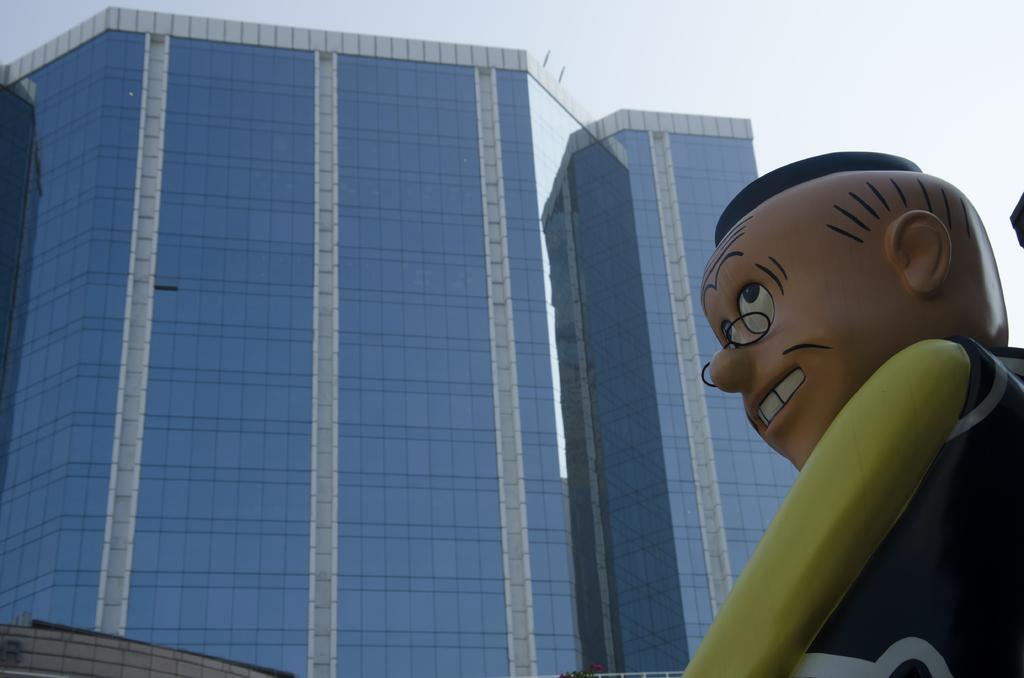What is the main subject of the image? There is a statue of a person in the image. What colors are used for the statue? The statue is in black and green color. What can be seen in the background of the image? There is a blue color building in the background of the image. How would you describe the sky in the image? The sky is white in the image. What type of cloth is draped over the dog in the image? There is no dog or cloth present in the image; it features a statue of a person and a blue color building in the background. 